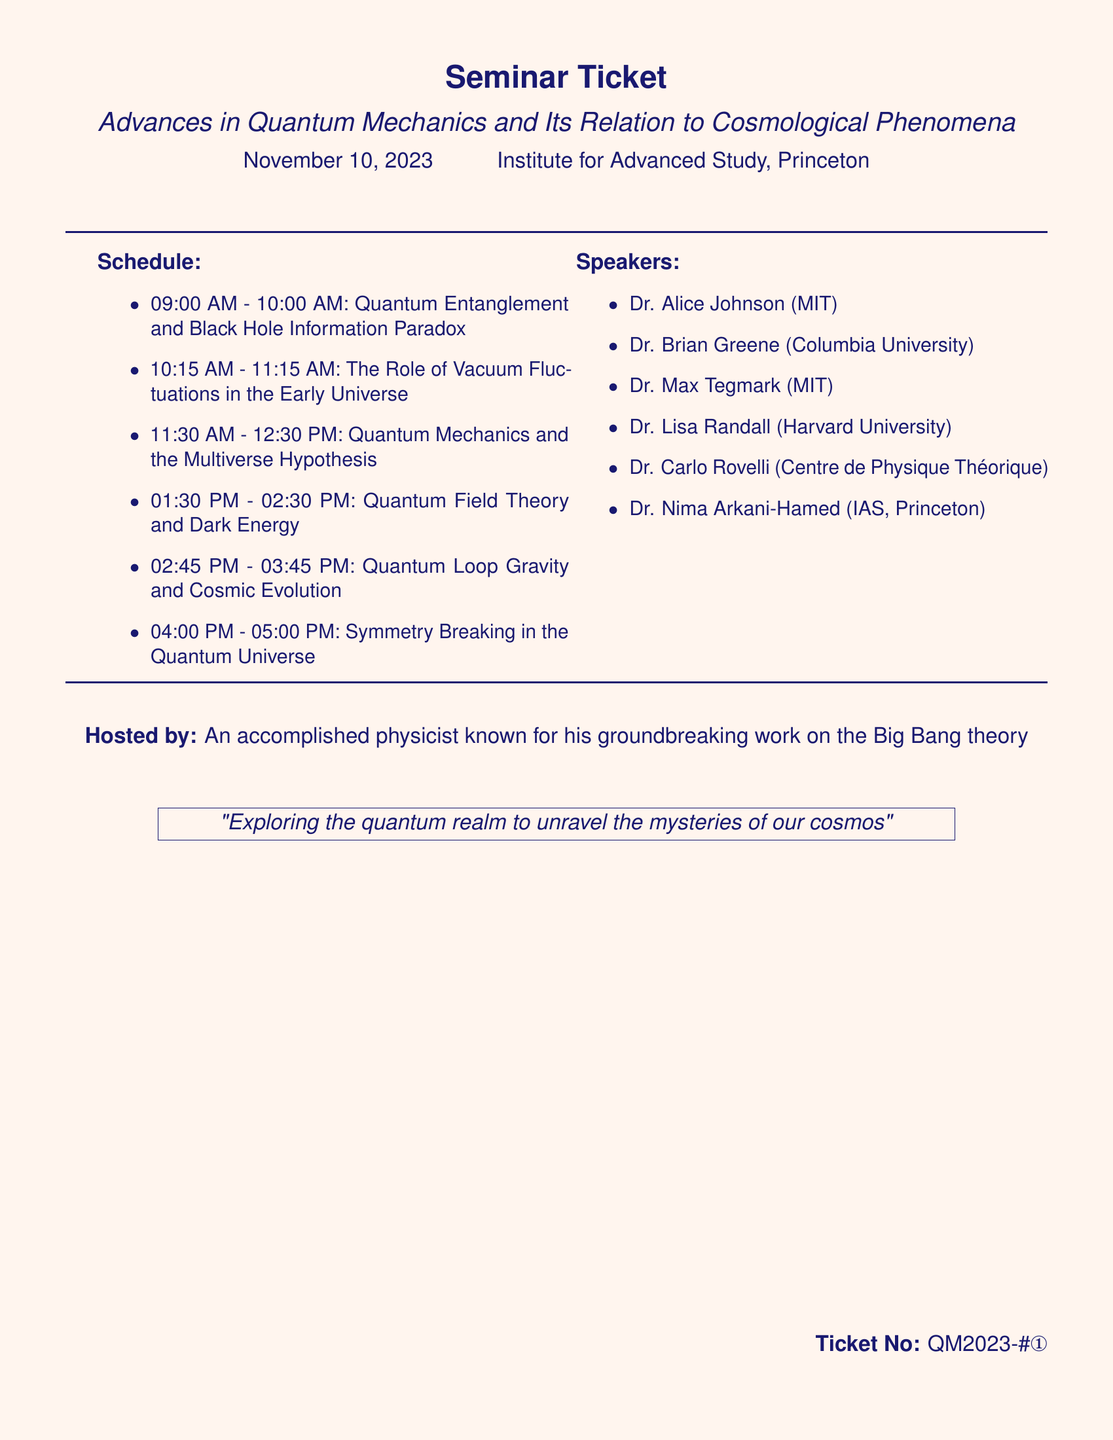What is the date of the seminar? The date of the seminar is explicitly stated in the document.
Answer: November 10, 2023 Who is the host of the seminar? The host is mentioned at the end of the document.
Answer: An accomplished physicist known for his groundbreaking work on the Big Bang theory What is the title of the first topic? The title for the first time slot is listed in the schedule section.
Answer: Quantum Entanglement and Black Hole Information Paradox How many speakers are listed? The number of speakers can be counted from the speakers' section of the document.
Answer: Six What time does the last topic start? The start time for the last topic can be found in the schedule provided.
Answer: 04:00 PM Which institution is Dr. Brian Greene affiliated with? Dr. Brian Greene's affiliation is explicitly mentioned next to his name in the document.
Answer: Columbia University What is the topic of the seminar right after lunch? The schedule indicates the topic that follows the lunch break at 01:30 PM.
Answer: Quantum Field Theory and Dark Energy What is the theme of the seminar as described in the document? The theme is captured in the quote at the bottom of the ticket.
Answer: Exploring the quantum realm to unravel the mysteries of our cosmos 